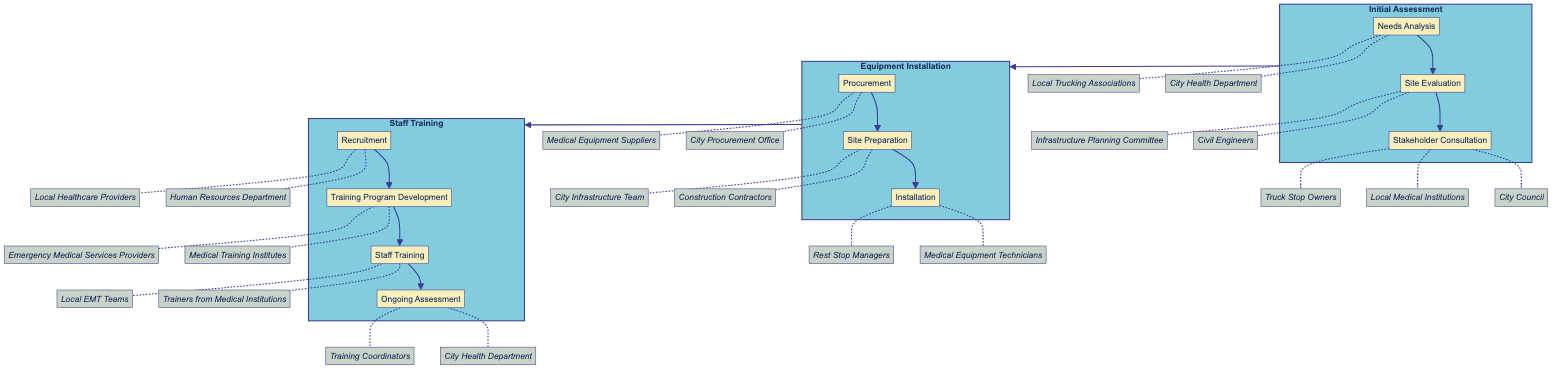What are the three steps involved in the Initial Assessment phase? The Initial Assessment phase consists of three steps: Needs Analysis, Site Evaluation, and Stakeholder Consultation. These steps are listed sequentially under their respective phase in the diagram.
Answer: Needs Analysis, Site Evaluation, Stakeholder Consultation Which entity is responsible for conducting the Needs Analysis? The Needs Analysis step is conducted by the City Health Department and Local Trucking Associations, indicated by the entities connected to this step in the diagram.
Answer: City Health Department, Local Trucking Associations How many phases are there in the roadmap? The diagram clearly indicates three main phases: Initial Assessment, Equipment Installation, and Staff Training, making it easy to count the distinct phases presented.
Answer: 3 What follows the Site Preparation step in the Equipment Installation phase? The diagram shows that Site Preparation directly leads to the Installation step, creating a flow where Site Preparation is sequentially followed by Installation.
Answer: Installation Which organization is involved in the Ongoing Assessment step? The diagram indicates that the Ongoing Assessment step involves the City Health Department and Training Coordinators, as these entities are directly linked to this step.
Answer: City Health Department, Training Coordinators What is the first step in the Staff Training phase? The first step in the Staff Training phase is Recruitment, as indicated by its position at the beginning of that phase in the diagram.
Answer: Recruitment How many steps are included in the Equipment Installation phase? The Equipment Installation phase contains three steps: Procurement, Site Preparation, and Installation. This can be determined by counting the steps listed in that particular phase of the diagram.
Answer: 3 What type of training is included in the Staff Training phase? The Staff Training phase includes training focused on emergency response, equipment usage, and telemedicine protocols, as noted in the description of the Staff Training step within this phase.
Answer: Emergency response, equipment usage, telemedicine protocols What is the purpose of the Stakeholder Consultation step? The Stakeholder Consultation step is designed to engage with key stakeholders to discuss plans and gather input, as clearly described in the diagram.
Answer: Discuss plans, gather input 